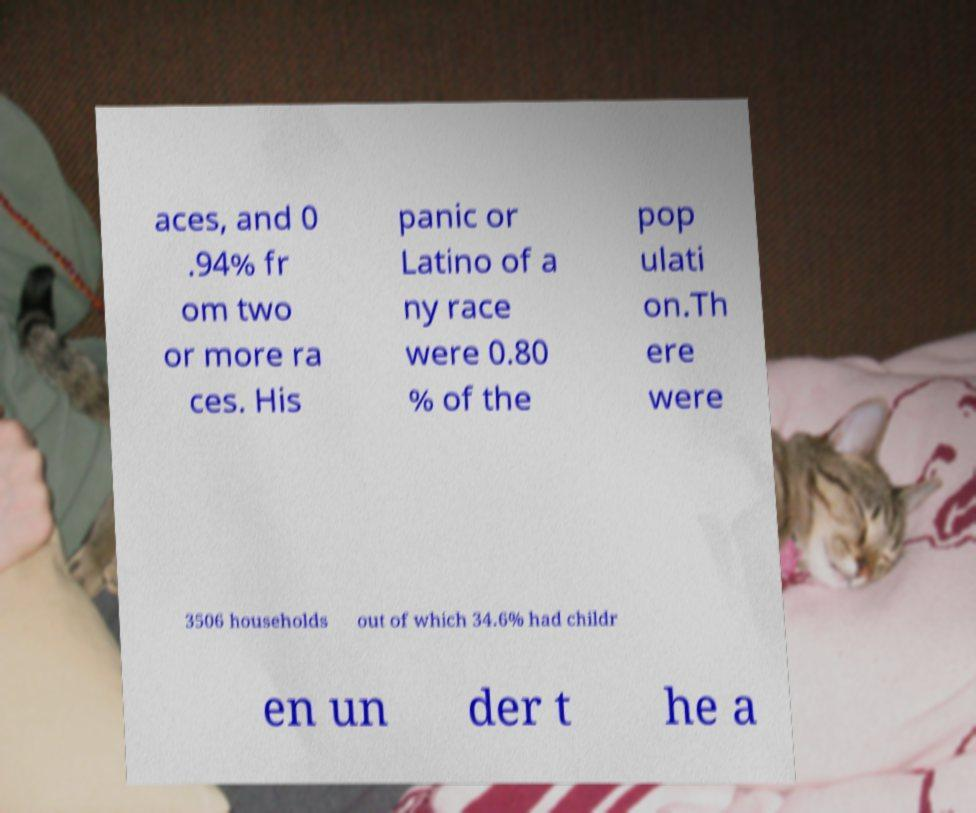Can you read and provide the text displayed in the image?This photo seems to have some interesting text. Can you extract and type it out for me? aces, and 0 .94% fr om two or more ra ces. His panic or Latino of a ny race were 0.80 % of the pop ulati on.Th ere were 3506 households out of which 34.6% had childr en un der t he a 